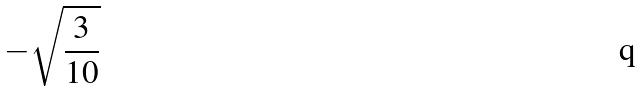Convert formula to latex. <formula><loc_0><loc_0><loc_500><loc_500>- \sqrt { \frac { 3 } { 1 0 } }</formula> 